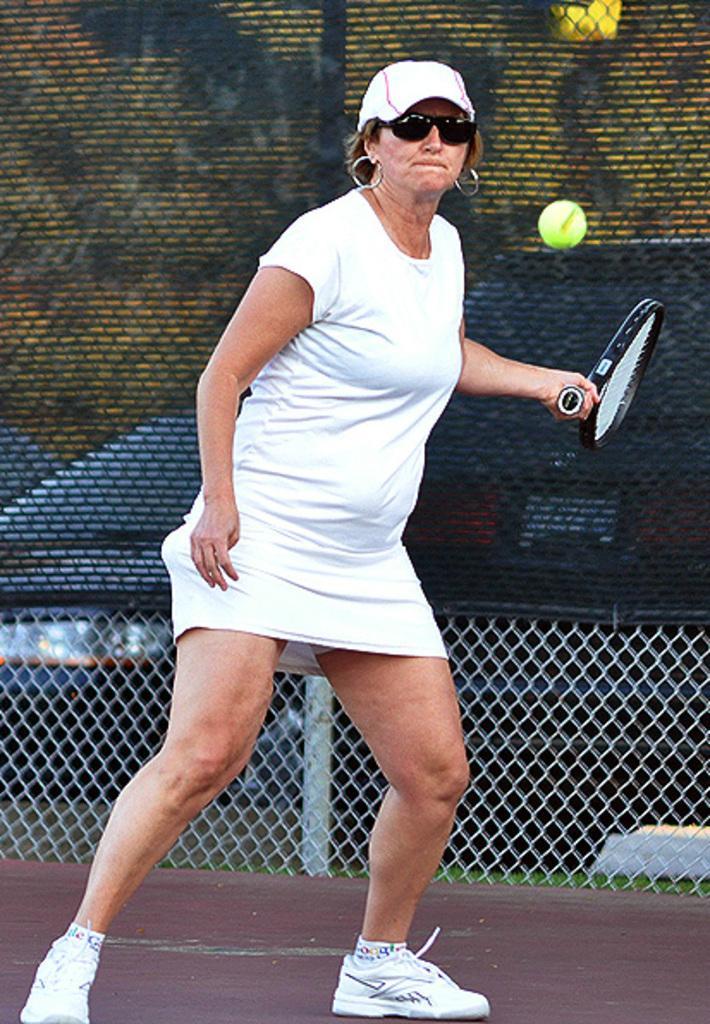Can you describe this image briefly? in this image i can see a woman playing tennis, holding a tennis bat. behind her there is fencing. 